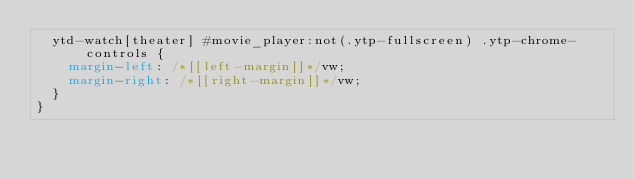<code> <loc_0><loc_0><loc_500><loc_500><_CSS_>  ytd-watch[theater] #movie_player:not(.ytp-fullscreen) .ytp-chrome-controls {
    margin-left: /*[[left-margin]]*/vw;
    margin-right: /*[[right-margin]]*/vw;
  }
}</code> 